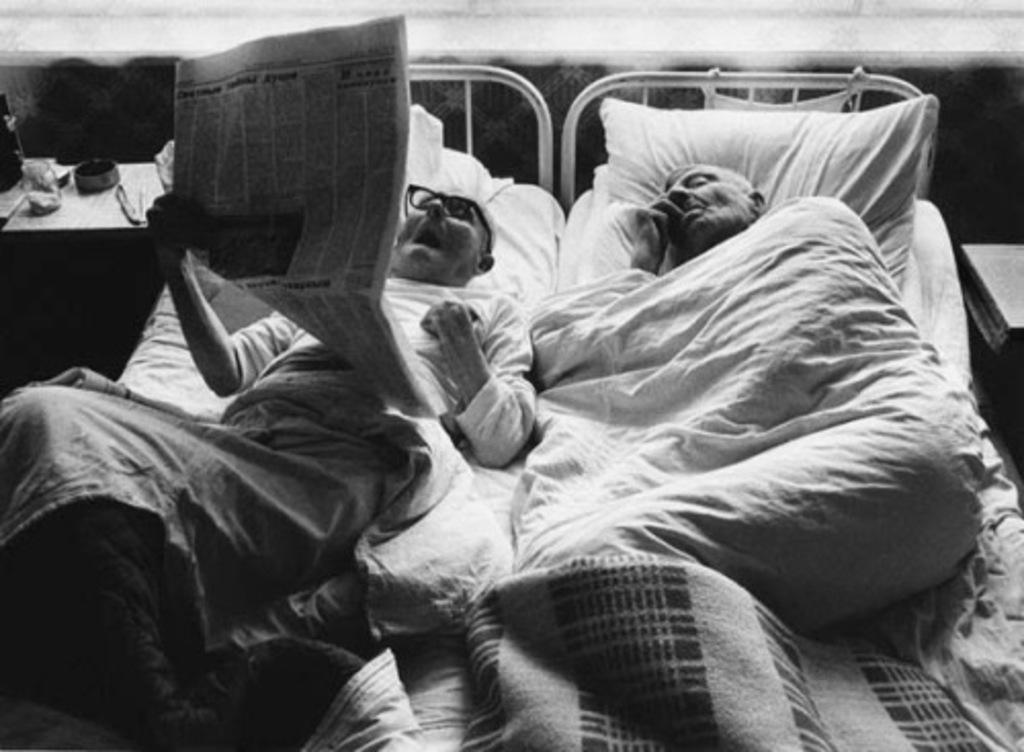Please provide a concise description of this image. This is a black and white picture. Here we can see two men laying on the bed. This man is reading a newspaper and he is holding a newspaper in his hand. Near to this bed there is a table and on the table we can see a bowl and a knife. 